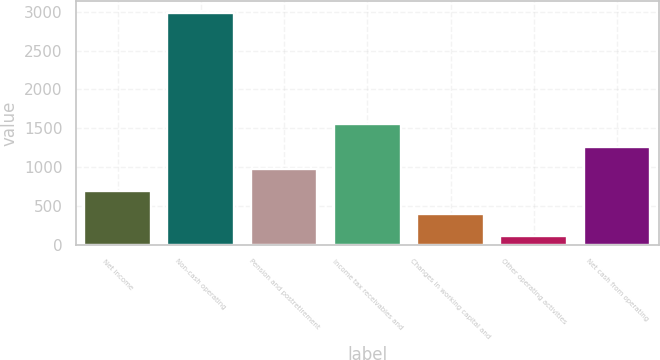Convert chart. <chart><loc_0><loc_0><loc_500><loc_500><bar_chart><fcel>Net income<fcel>Non-cash operating<fcel>Pension and postretirement<fcel>Income tax receivables and<fcel>Changes in working capital and<fcel>Other operating activities<fcel>Net cash from operating<nl><fcel>689<fcel>2989<fcel>976.5<fcel>1551.5<fcel>401.5<fcel>114<fcel>1264<nl></chart> 